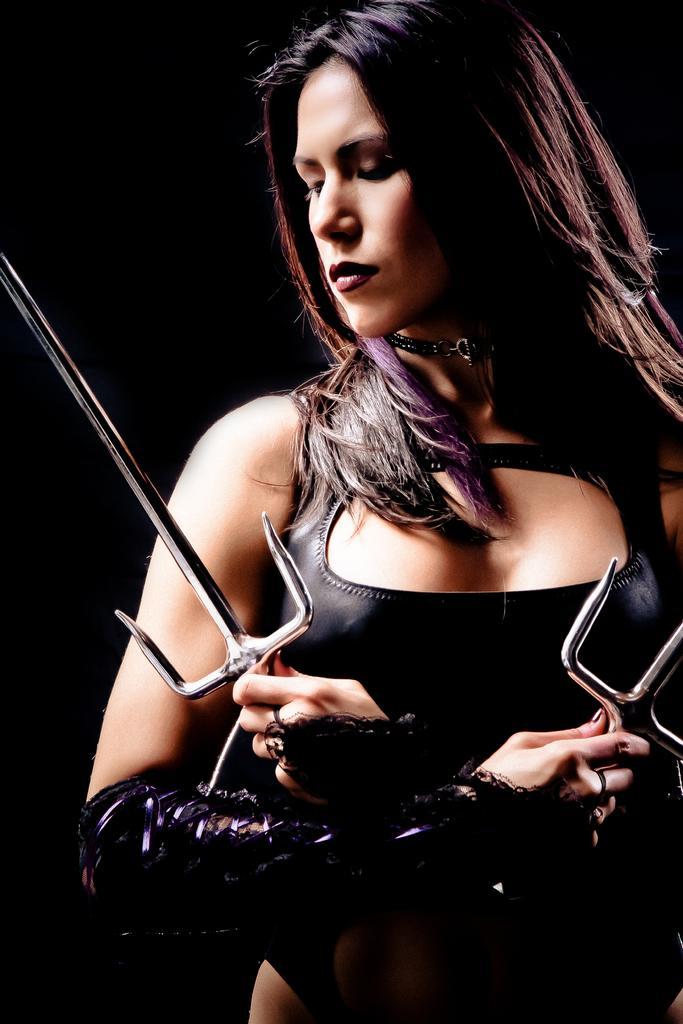Could you give a brief overview of what you see in this image? In this picture we can see a woman and there is a dark background. 